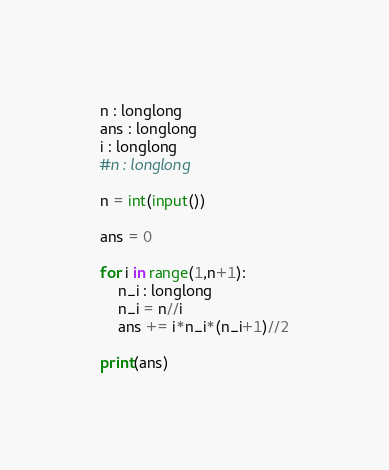<code> <loc_0><loc_0><loc_500><loc_500><_Cython_>n : longlong
ans : longlong
i : longlong
#n : longlong

n = int(input())

ans = 0

for i in range(1,n+1):
    n_i : longlong
    n_i = n//i
    ans += i*n_i*(n_i+1)//2
    
print(ans)</code> 